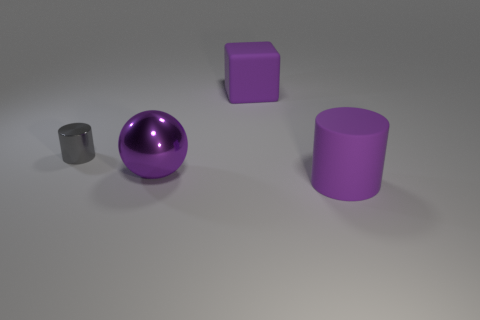What colors are the objects in the image? The objects in the image are various shades of purple and grey. Specifically, there's a shiny purple sphere, a matte grey cylinder, and two purple blocks, one appearing to be of a matte finish and the other with a harder to determine surface texture due to the lighting. 